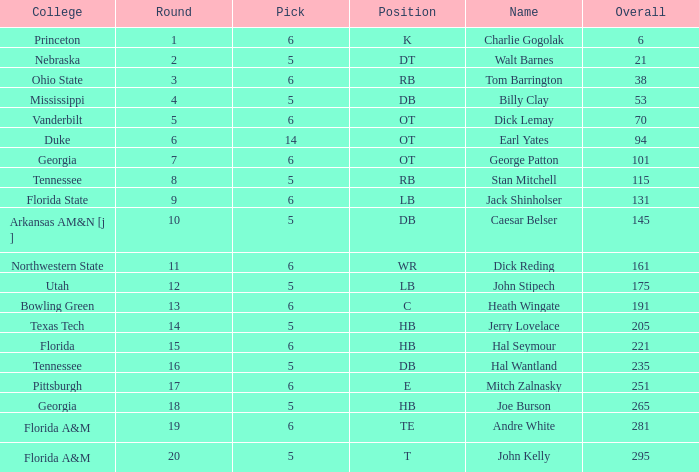What is the highest Pick, when Round is greater than 15, and when College is "Tennessee"? 5.0. 